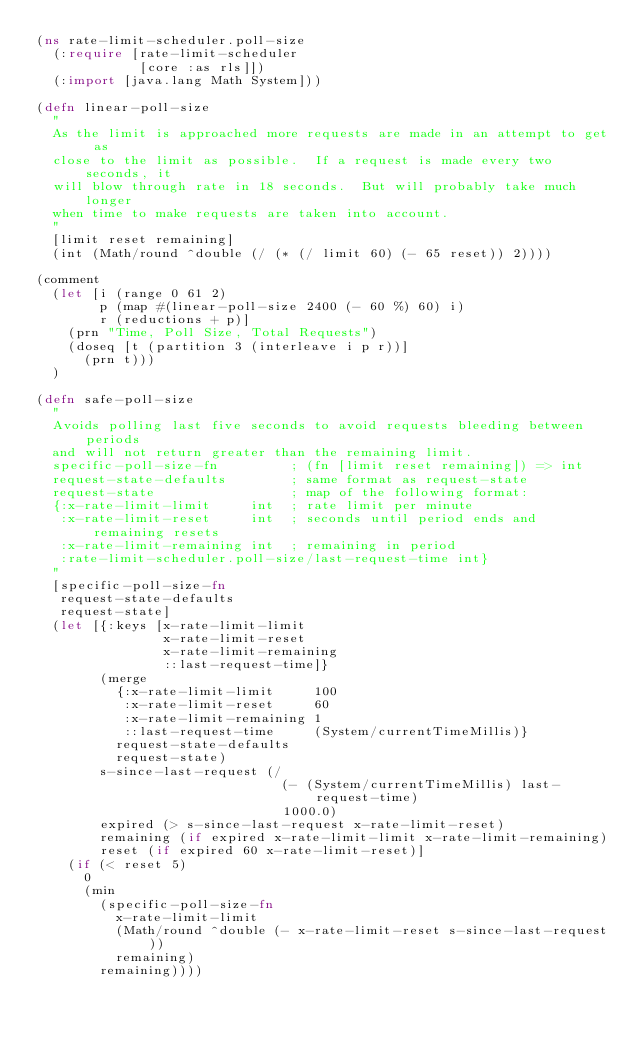Convert code to text. <code><loc_0><loc_0><loc_500><loc_500><_Clojure_>(ns rate-limit-scheduler.poll-size
  (:require [rate-limit-scheduler
             [core :as rls]])
  (:import [java.lang Math System]))

(defn linear-poll-size
  "
  As the limit is approached more requests are made in an attempt to get as
  close to the limit as possible.  If a request is made every two seconds, it
  will blow through rate in 18 seconds.  But will probably take much longer
  when time to make requests are taken into account.
  "
  [limit reset remaining]
  (int (Math/round ^double (/ (* (/ limit 60) (- 65 reset)) 2))))

(comment
  (let [i (range 0 61 2)
        p (map #(linear-poll-size 2400 (- 60 %) 60) i)
        r (reductions + p)]
    (prn "Time, Poll Size, Total Requests")
    (doseq [t (partition 3 (interleave i p r))]
      (prn t)))
  )

(defn safe-poll-size
  "
  Avoids polling last five seconds to avoid requests bleeding between periods
  and will not return greater than the remaining limit.
  specific-poll-size-fn         ; (fn [limit reset remaining]) => int
  request-state-defaults        ; same format as request-state
  request-state                 ; map of the following format:
  {:x-rate-limit-limit     int  ; rate limit per minute
   :x-rate-limit-reset     int  ; seconds until period ends and remaining resets
   :x-rate-limit-remaining int  ; remaining in period
   :rate-limit-scheduler.poll-size/last-request-time int}
  "
  [specific-poll-size-fn
   request-state-defaults
   request-state]
  (let [{:keys [x-rate-limit-limit
                x-rate-limit-reset
                x-rate-limit-remaining
                ::last-request-time]}
        (merge
          {:x-rate-limit-limit     100
           :x-rate-limit-reset     60
           :x-rate-limit-remaining 1
           ::last-request-time     (System/currentTimeMillis)}
          request-state-defaults
          request-state)
        s-since-last-request (/
                               (- (System/currentTimeMillis) last-request-time)
                               1000.0)
        expired (> s-since-last-request x-rate-limit-reset)
        remaining (if expired x-rate-limit-limit x-rate-limit-remaining)
        reset (if expired 60 x-rate-limit-reset)]
    (if (< reset 5)
      0
      (min
        (specific-poll-size-fn
          x-rate-limit-limit
          (Math/round ^double (- x-rate-limit-reset s-since-last-request))
          remaining)
        remaining))))</code> 